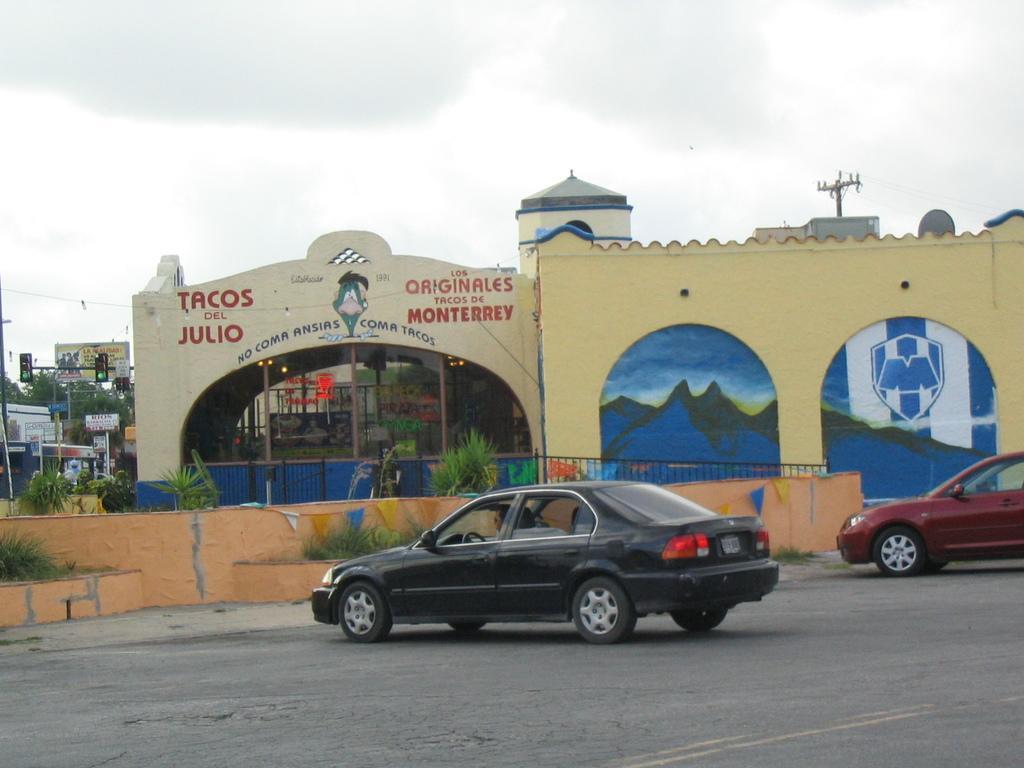In one or two sentences, can you explain what this image depicts? In this image there are two cars parked on the road. In the background there is a wall on which there is painting. At the top there is the sky. On the left side there is a traffic signal light, under which there are stores and hoardings. In the middle there is a glass window. There are small plants beside the wall. Above the building there is a dish antenna. 